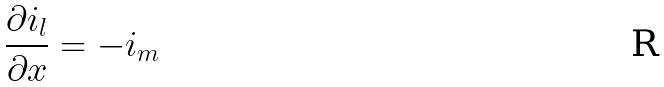Convert formula to latex. <formula><loc_0><loc_0><loc_500><loc_500>\frac { \partial i _ { l } } { \partial x } = - i _ { m }</formula> 